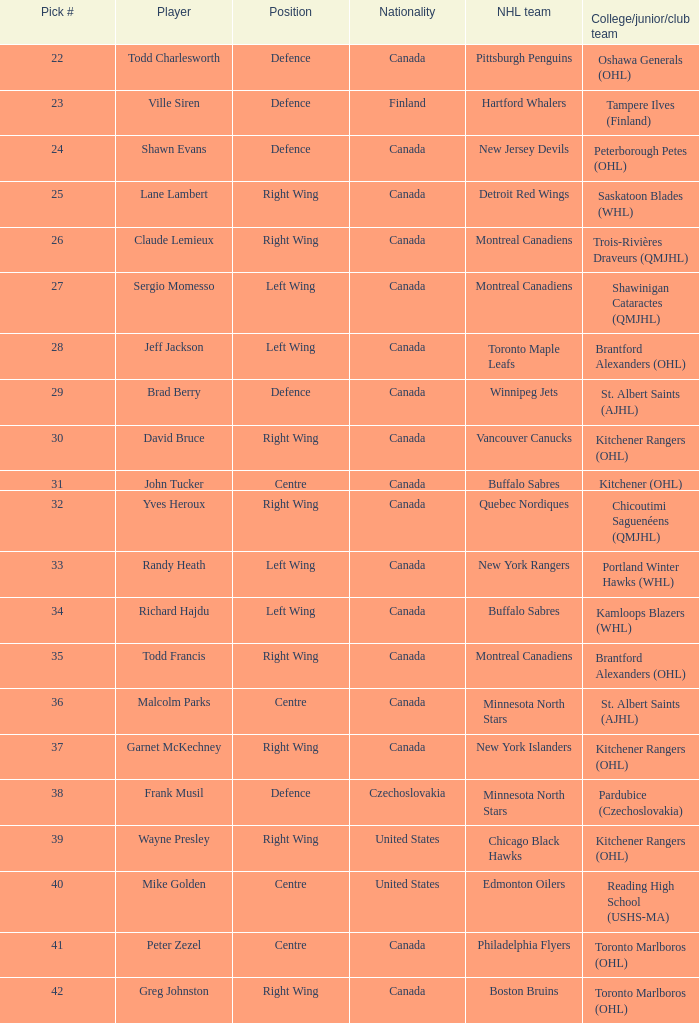What is the count of the nhl team named winnipeg jets? 1.0. 